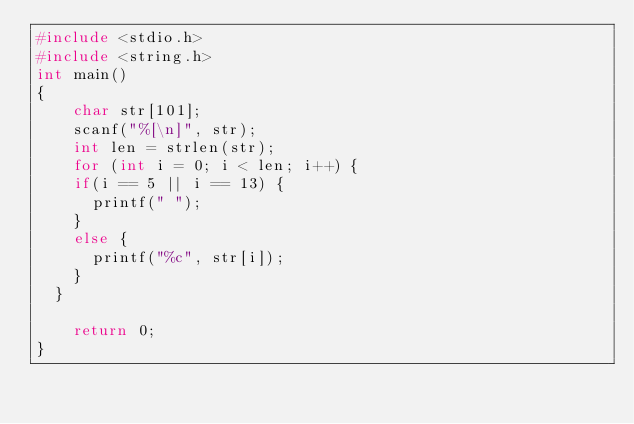Convert code to text. <code><loc_0><loc_0><loc_500><loc_500><_C_>#include <stdio.h>
#include <string.h>
int main()
{
    char str[101];
    scanf("%[\n]", str);
    int len = strlen(str);
    for (int i = 0; i < len; i++) {
		if(i == 5 || i == 13) {
			printf(" ");
		}
		else {
			printf("%c", str[i]);
		}
	}

    return 0;
}</code> 